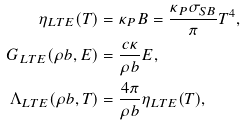<formula> <loc_0><loc_0><loc_500><loc_500>\eta _ { L T E } ( T ) & = \kappa _ { P } B = \frac { \kappa _ { P } \sigma _ { S B } } { \pi } T ^ { 4 } , \\ G _ { L T E } ( \rho b , E ) & = \frac { c \kappa } { \rho b } E , \\ \Lambda _ { L T E } ( \rho b , T ) & = \frac { 4 \pi } { \rho b } \eta _ { L T E } ( T ) ,</formula> 